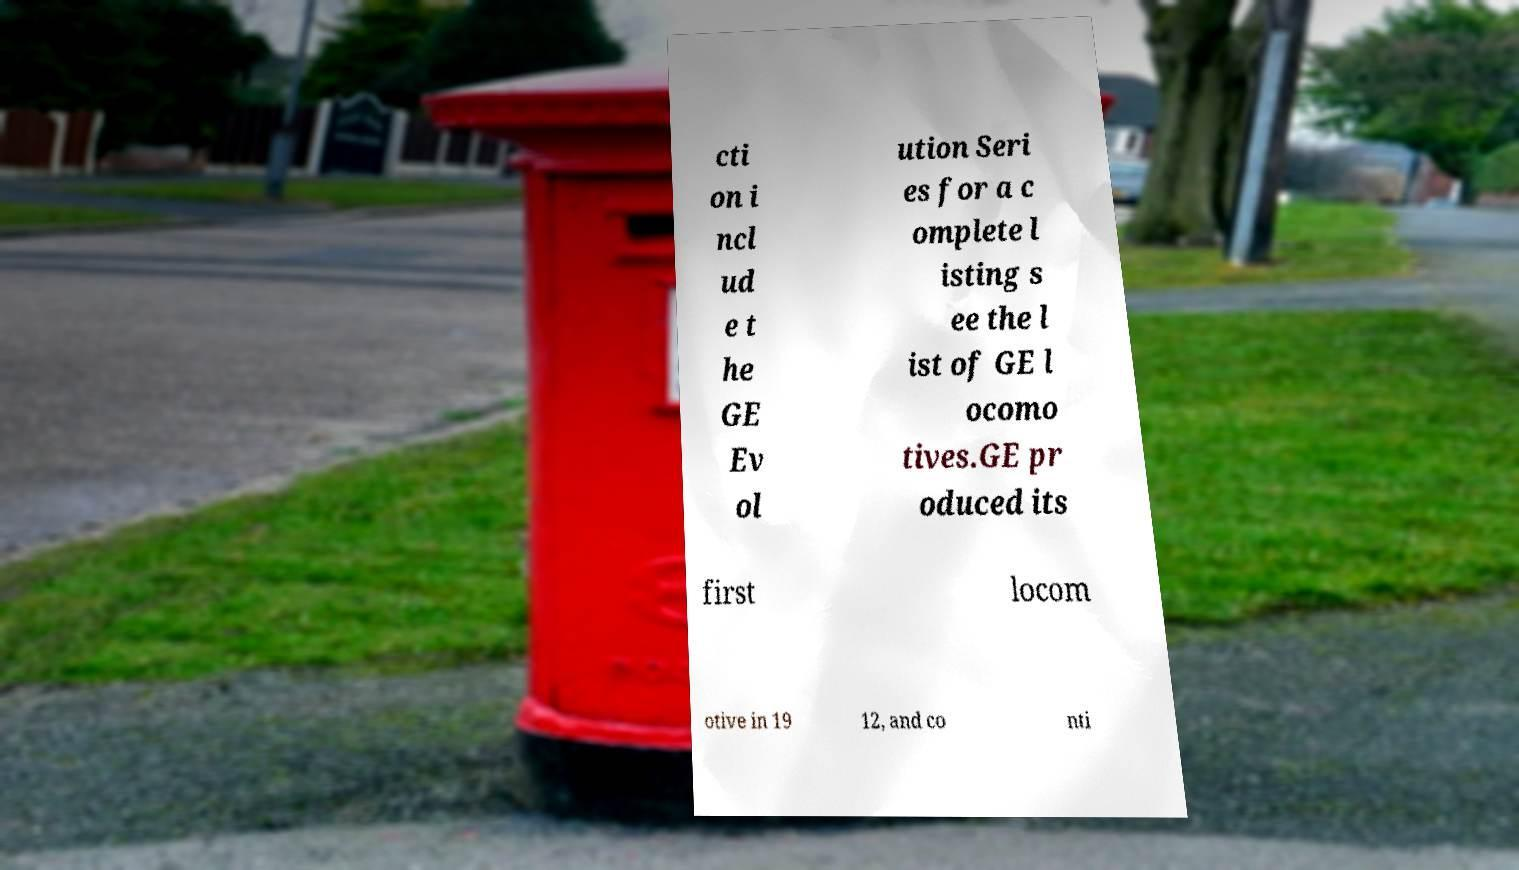What messages or text are displayed in this image? I need them in a readable, typed format. cti on i ncl ud e t he GE Ev ol ution Seri es for a c omplete l isting s ee the l ist of GE l ocomo tives.GE pr oduced its first locom otive in 19 12, and co nti 